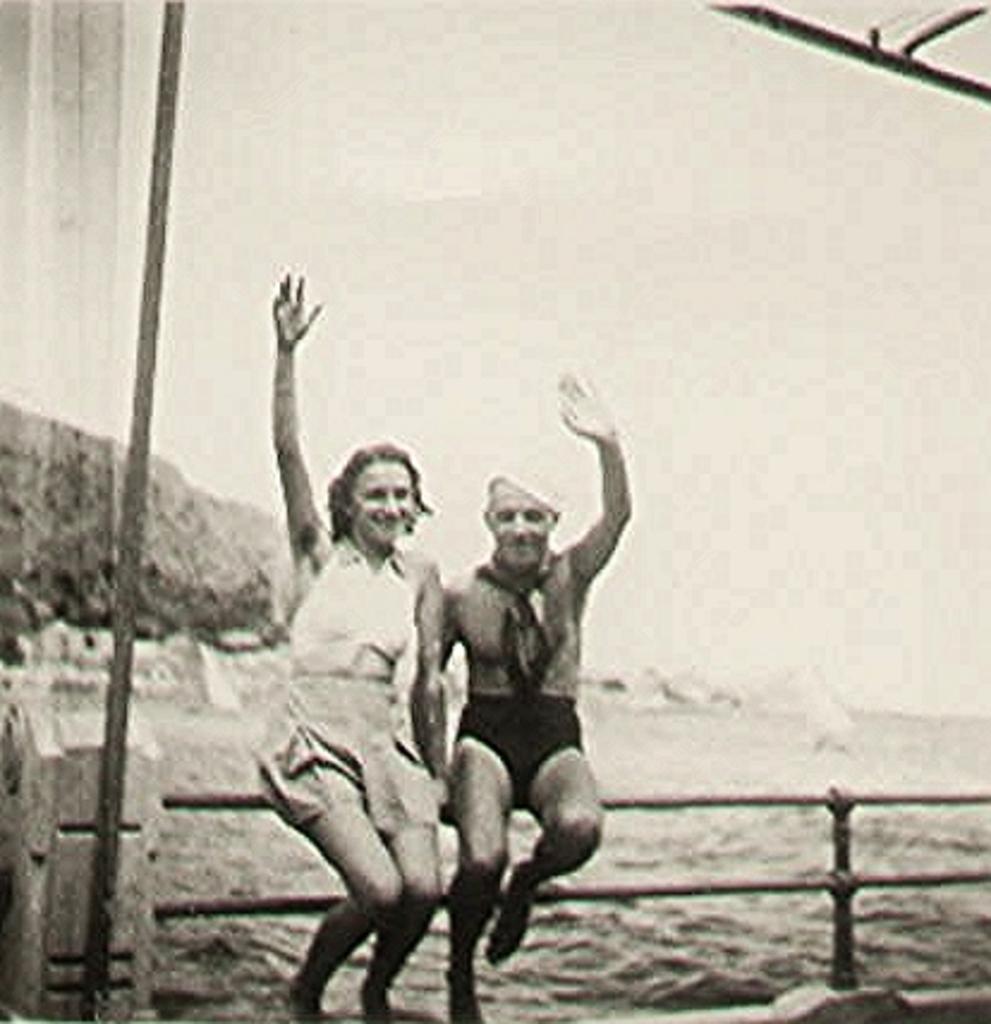Describe this image in one or two sentences. This is a black and white image. 2 people are sitting on a fencing. There is water at the back. 